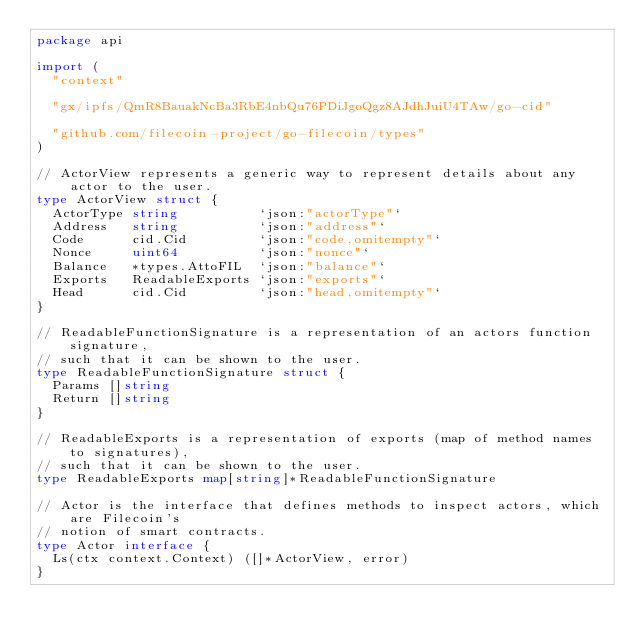Convert code to text. <code><loc_0><loc_0><loc_500><loc_500><_Go_>package api

import (
	"context"

	"gx/ipfs/QmR8BauakNcBa3RbE4nbQu76PDiJgoQgz8AJdhJuiU4TAw/go-cid"

	"github.com/filecoin-project/go-filecoin/types"
)

// ActorView represents a generic way to represent details about any actor to the user.
type ActorView struct {
	ActorType string          `json:"actorType"`
	Address   string          `json:"address"`
	Code      cid.Cid         `json:"code,omitempty"`
	Nonce     uint64          `json:"nonce"`
	Balance   *types.AttoFIL  `json:"balance"`
	Exports   ReadableExports `json:"exports"`
	Head      cid.Cid         `json:"head,omitempty"`
}

// ReadableFunctionSignature is a representation of an actors function signature,
// such that it can be shown to the user.
type ReadableFunctionSignature struct {
	Params []string
	Return []string
}

// ReadableExports is a representation of exports (map of method names to signatures),
// such that it can be shown to the user.
type ReadableExports map[string]*ReadableFunctionSignature

// Actor is the interface that defines methods to inspect actors, which are Filecoin's
// notion of smart contracts.
type Actor interface {
	Ls(ctx context.Context) ([]*ActorView, error)
}
</code> 